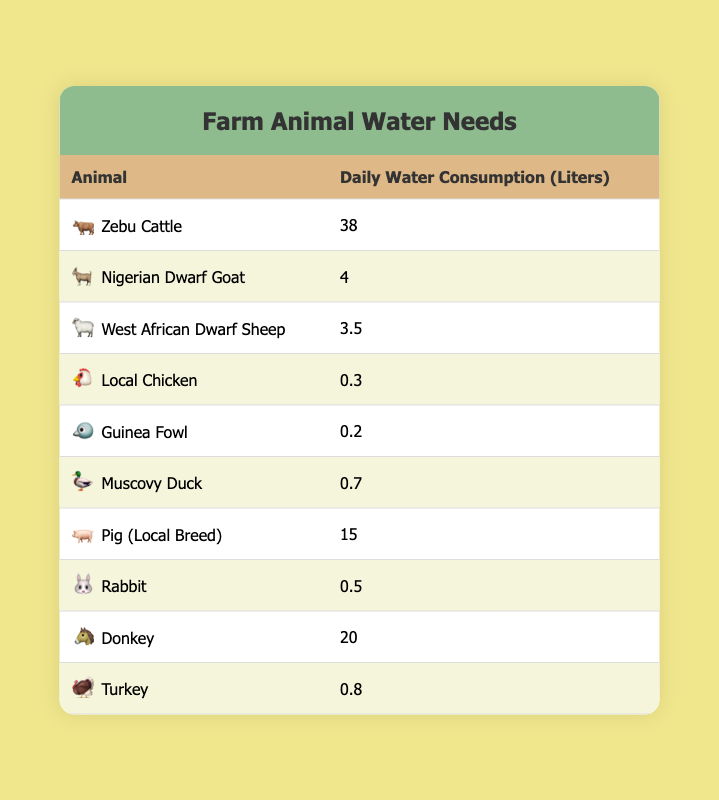What is the daily water consumption for Zebu Cattle? According to the table, Zebu Cattle consumes 38 liters of water daily.
Answer: 38 liters How much water do Local Chickens consume daily? The table indicates that Local Chickens have a daily water consumption of 0.3 liters.
Answer: 0.3 liters What is the total daily water consumption for the Nigerian Dwarf Goat and the West African Dwarf Sheep combined? From the table, we find that the Nigerian Dwarf Goat consumes 4 liters and the West African Dwarf Sheep consumes 3.5 liters. Adding them gives 4 + 3.5 = 7.5 liters.
Answer: 7.5 liters Is the daily water consumption of a Pig (Local Breed) greater than that of a Donkey? The Pig consumes 15 liters as shown in the table, while the Donkey consumes 20 liters. Since 15 is less than 20, the answer is no.
Answer: No What is the average daily water consumption of all the animals listed in the table? First, we sum all the water consumption values: 38 + 4 + 3.5 + 0.3 + 0.2 + 0.7 + 15 + 0.5 + 20 + 0.8 = 83.0 liters. There are 10 animals, so the average is 83.0 / 10 = 8.3 liters.
Answer: 8.3 liters Which animal consumes the least amount of water daily? By examining the table, Guinea Fowl consumes the least at 0.2 liters daily.
Answer: Guinea Fowl What is the difference in daily water consumption between the Pig and the Zebu Cattle? The Pig consumes 15 liters and the Zebu Cattle consumes 38 liters. To find the difference, we subtract 15 from 38: 38 - 15 = 23 liters.
Answer: 23 liters Are any of the animals in the table listed as consuming over 30 liters of water daily? Inspecting the table, only Zebu Cattle has a consumption of 38 liters, which is above 30 liters, so the answer is yes.
Answer: Yes How many animals consume less than 1 liter of water daily? From the table, the animals that consume less than 1 liter are Local Chicken (0.3), Guinea Fowl (0.2), Muscovy Duck (0.7), Rabbit (0.5), and Turkey (0.8), totaling 5 animals.
Answer: 5 animals 